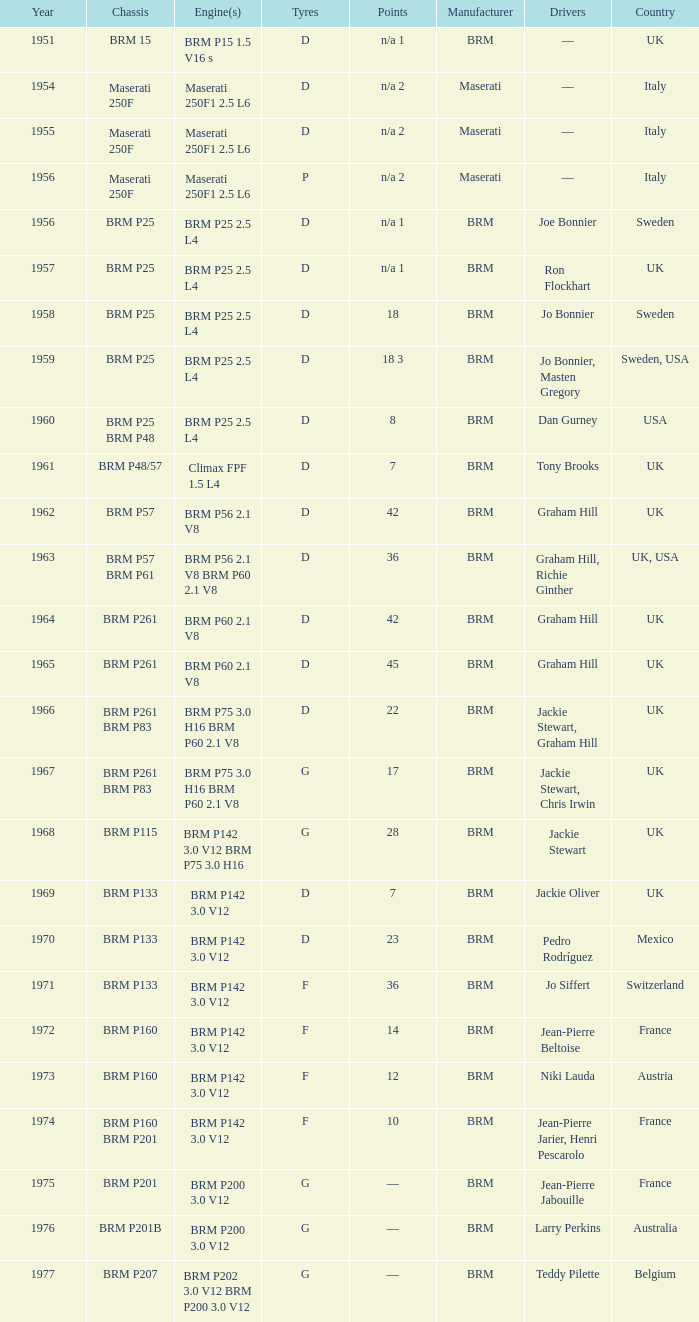What is the total number of years for the brm p202 3.0 v12 and brm p200 3.0 v12 engines? 1977.0. 